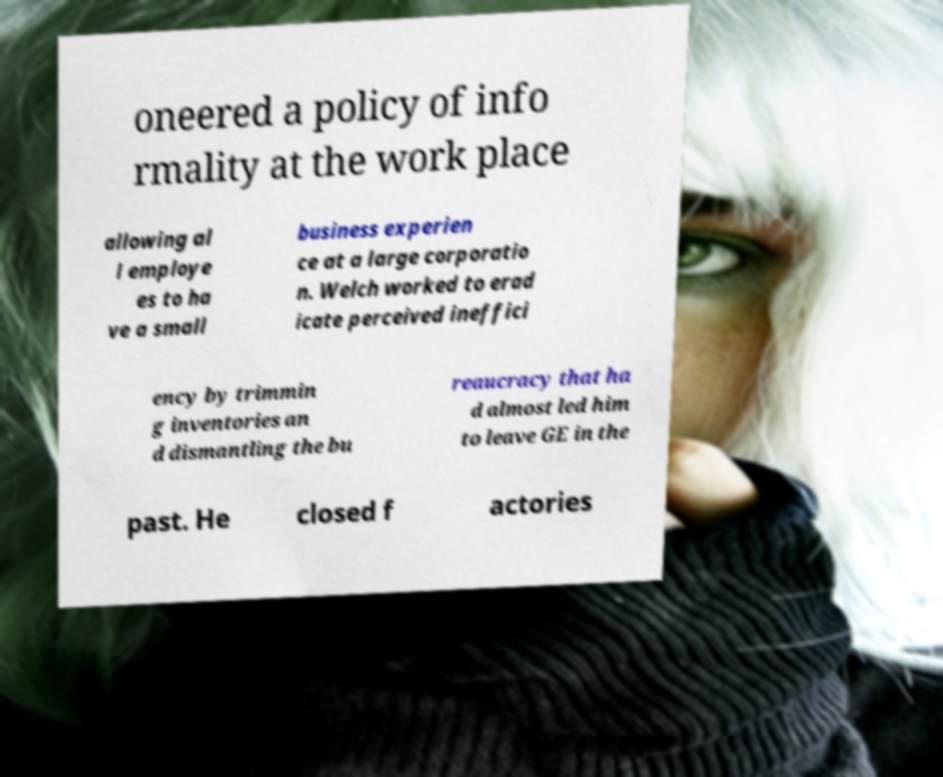Could you extract and type out the text from this image? oneered a policy of info rmality at the work place allowing al l employe es to ha ve a small business experien ce at a large corporatio n. Welch worked to erad icate perceived ineffici ency by trimmin g inventories an d dismantling the bu reaucracy that ha d almost led him to leave GE in the past. He closed f actories 